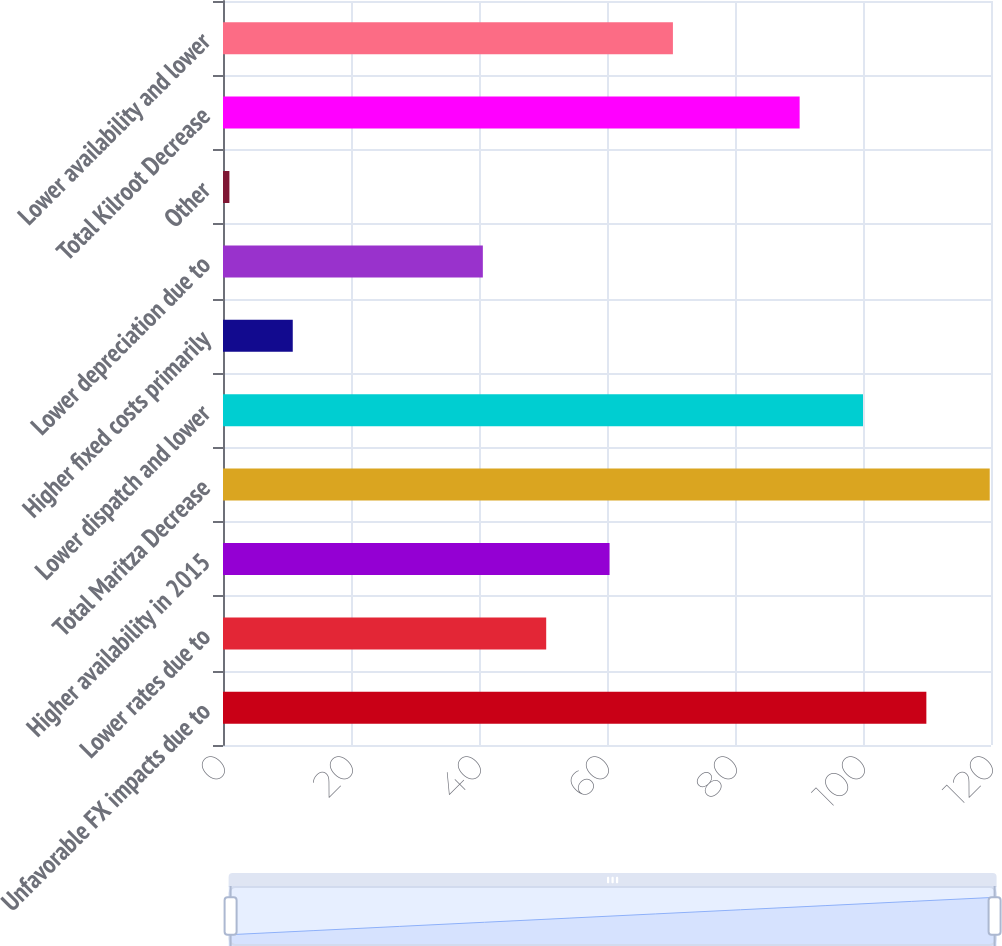Convert chart. <chart><loc_0><loc_0><loc_500><loc_500><bar_chart><fcel>Unfavorable FX impacts due to<fcel>Lower rates due to<fcel>Higher availability in 2015<fcel>Total Maritza Decrease<fcel>Lower dispatch and lower<fcel>Higher fixed costs primarily<fcel>Lower depreciation due to<fcel>Other<fcel>Total Kilroot Decrease<fcel>Lower availability and lower<nl><fcel>109.9<fcel>50.5<fcel>60.4<fcel>119.8<fcel>100<fcel>10.9<fcel>40.6<fcel>1<fcel>90.1<fcel>70.3<nl></chart> 